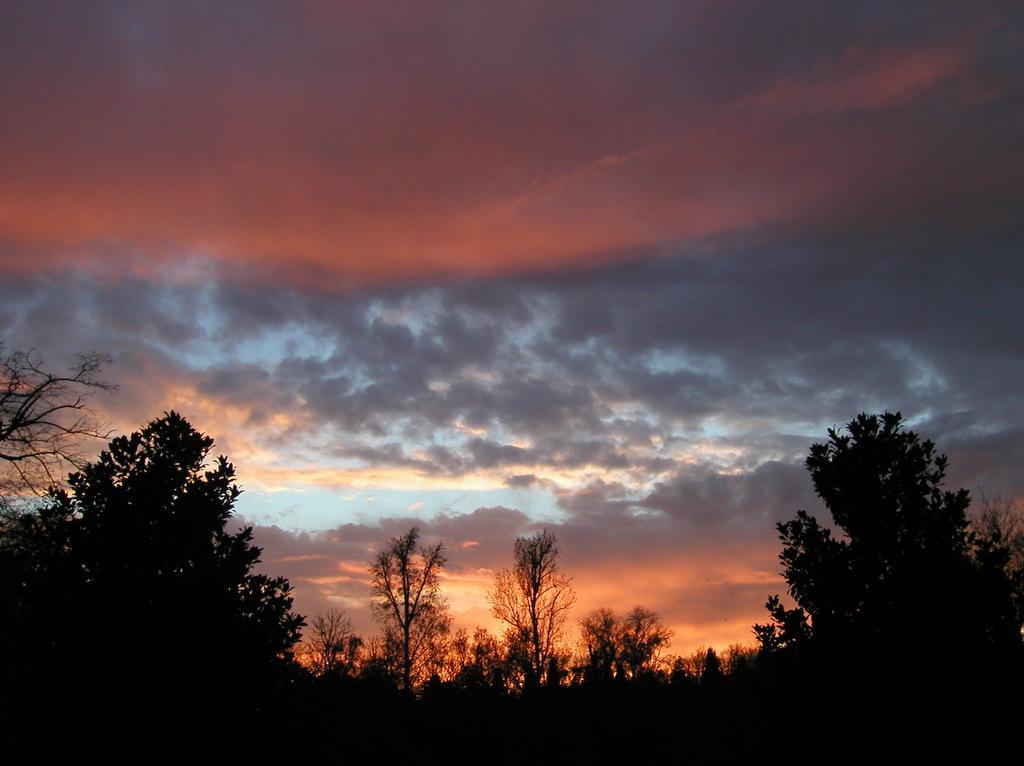Describe this image in one or two sentences. In this picture there are some trees in the front side. Behind there is a red color sunset sky with clouds. 